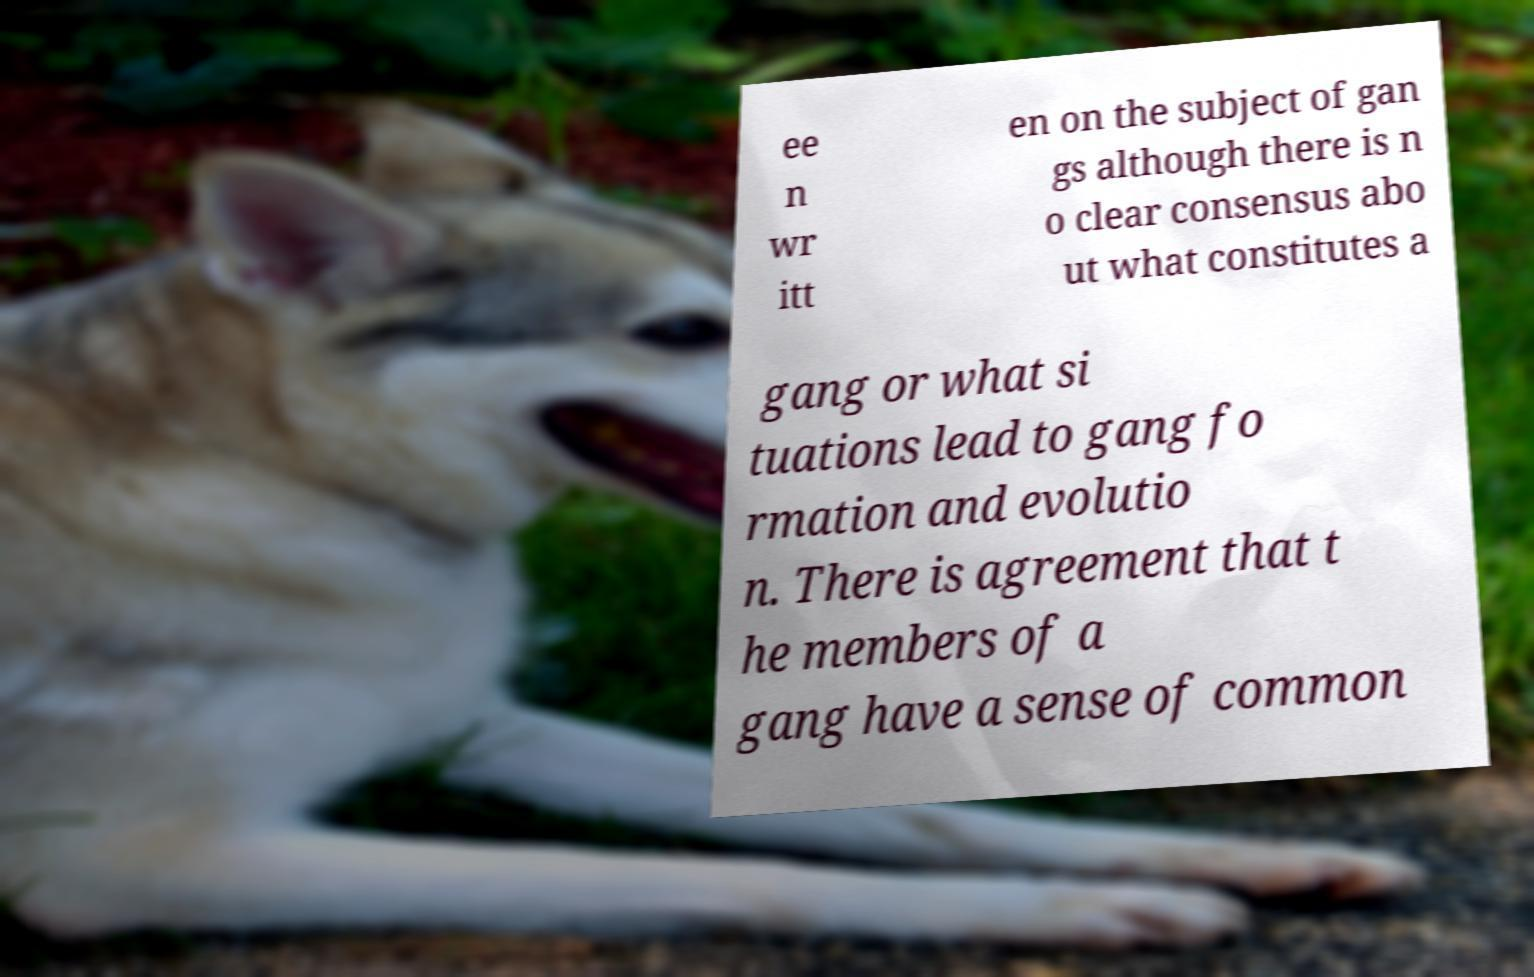Can you read and provide the text displayed in the image?This photo seems to have some interesting text. Can you extract and type it out for me? ee n wr itt en on the subject of gan gs although there is n o clear consensus abo ut what constitutes a gang or what si tuations lead to gang fo rmation and evolutio n. There is agreement that t he members of a gang have a sense of common 